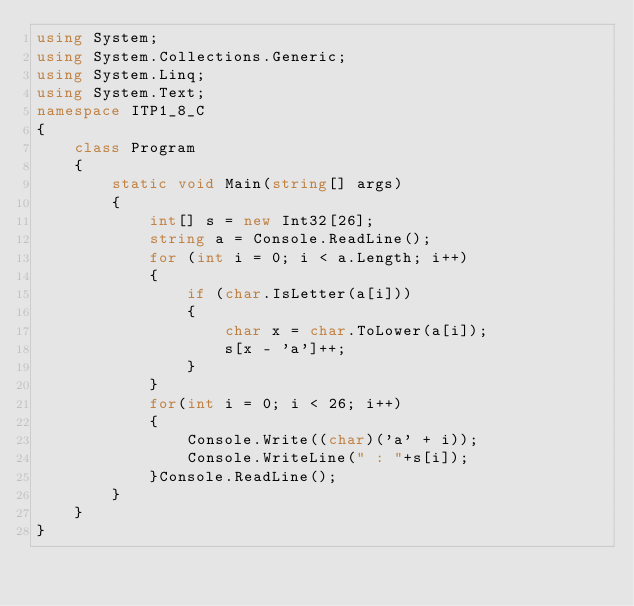<code> <loc_0><loc_0><loc_500><loc_500><_C#_>using System;
using System.Collections.Generic;
using System.Linq;
using System.Text;
namespace ITP1_8_C
{
    class Program
    {
        static void Main(string[] args)
        {
            int[] s = new Int32[26];
            string a = Console.ReadLine();
            for (int i = 0; i < a.Length; i++)
            {
                if (char.IsLetter(a[i]))
                {
                    char x = char.ToLower(a[i]);
                    s[x - 'a']++;
                }
            }
            for(int i = 0; i < 26; i++)
            {
                Console.Write((char)('a' + i));
                Console.WriteLine(" : "+s[i]);
            }Console.ReadLine();
        }
    }
}</code> 